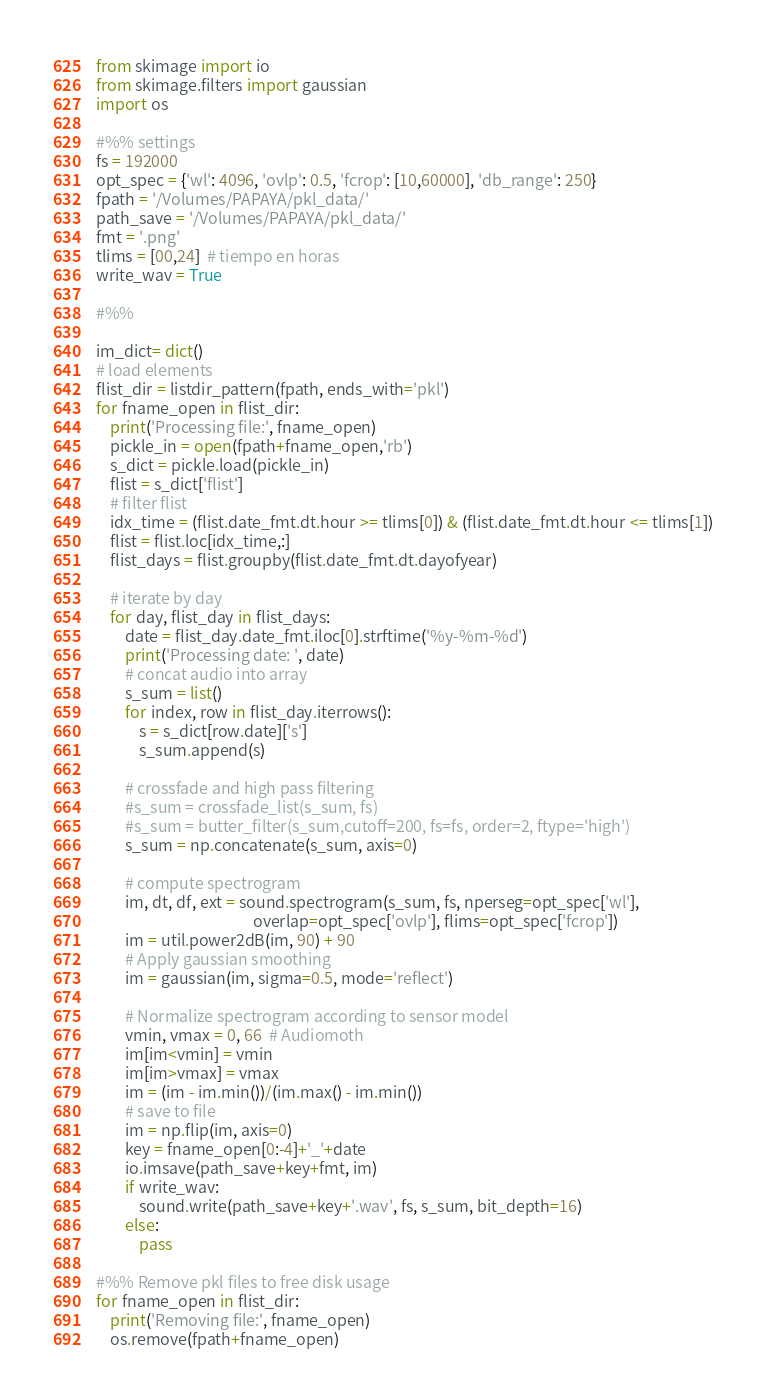Convert code to text. <code><loc_0><loc_0><loc_500><loc_500><_Python_>from skimage import io
from skimage.filters import gaussian
import os

#%% settings
fs = 192000
opt_spec = {'wl': 4096, 'ovlp': 0.5, 'fcrop': [10,60000], 'db_range': 250}
fpath = '/Volumes/PAPAYA/pkl_data/'
path_save = '/Volumes/PAPAYA/pkl_data/'
fmt = '.png'
tlims = [00,24]  # tiempo en horas
write_wav = True

#%%

im_dict= dict()
# load elements
flist_dir = listdir_pattern(fpath, ends_with='pkl')
for fname_open in flist_dir:
    print('Processing file:', fname_open)
    pickle_in = open(fpath+fname_open,'rb')
    s_dict = pickle.load(pickle_in)
    flist = s_dict['flist']
    # filter flist
    idx_time = (flist.date_fmt.dt.hour >= tlims[0]) & (flist.date_fmt.dt.hour <= tlims[1])
    flist = flist.loc[idx_time,:]
    flist_days = flist.groupby(flist.date_fmt.dt.dayofyear)
        
    # iterate by day    
    for day, flist_day in flist_days:
        date = flist_day.date_fmt.iloc[0].strftime('%y-%m-%d')
        print('Processing date: ', date)
        # concat audio into array
        s_sum = list()
        for index, row in flist_day.iterrows():
            s = s_dict[row.date]['s']
            s_sum.append(s)
        
        # crossfade and high pass filtering
        #s_sum = crossfade_list(s_sum, fs)
        #s_sum = butter_filter(s_sum,cutoff=200, fs=fs, order=2, ftype='high')
        s_sum = np.concatenate(s_sum, axis=0)
        
        # compute spectrogram
        im, dt, df, ext = sound.spectrogram(s_sum, fs, nperseg=opt_spec['wl'],
                                            overlap=opt_spec['ovlp'], flims=opt_spec['fcrop'])
        im = util.power2dB(im, 90) + 90
        # Apply gaussian smoothing
        im = gaussian(im, sigma=0.5, mode='reflect')
        
        # Normalize spectrogram according to sensor model         
        vmin, vmax = 0, 66  # Audiomoth
        im[im<vmin] = vmin
        im[im>vmax] = vmax
        im = (im - im.min())/(im.max() - im.min())
        # save to file
        im = np.flip(im, axis=0)
        key = fname_open[0:-4]+'_'+date
        io.imsave(path_save+key+fmt, im)
        if write_wav:
            sound.write(path_save+key+'.wav', fs, s_sum, bit_depth=16)
        else:
            pass
            
#%% Remove pkl files to free disk usage
for fname_open in flist_dir:
    print('Removing file:', fname_open)
    os.remove(fpath+fname_open)
</code> 